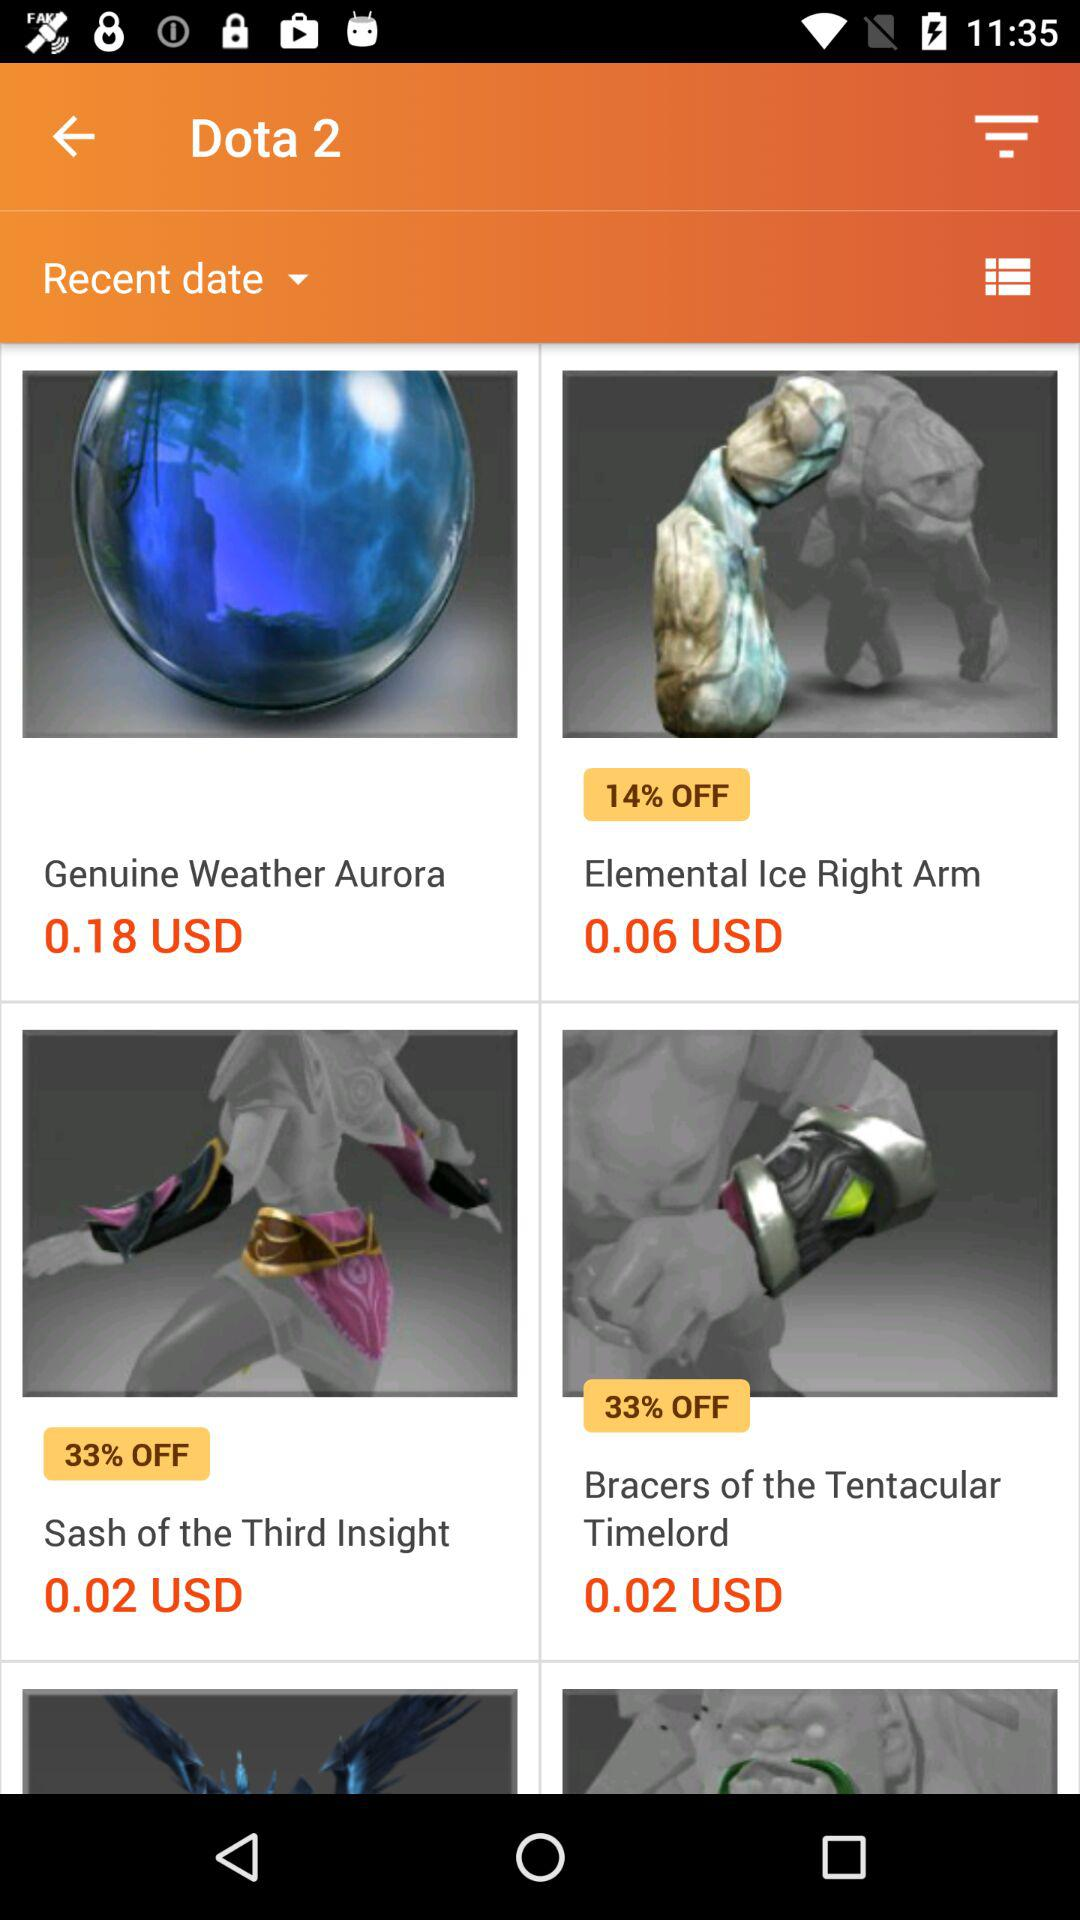What is the price of "Weather Aurora"? The price of "Weather Aurora" is 0.18 USD. 